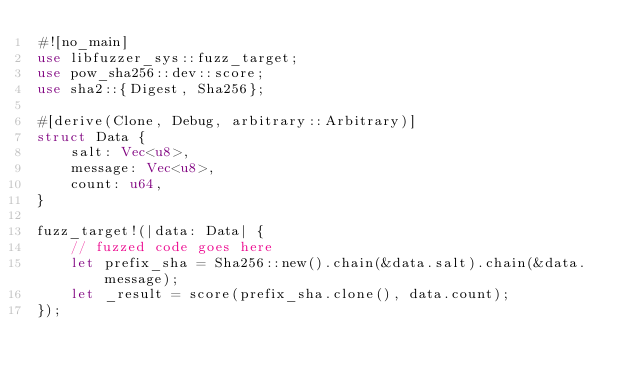Convert code to text. <code><loc_0><loc_0><loc_500><loc_500><_Rust_>#![no_main]
use libfuzzer_sys::fuzz_target;
use pow_sha256::dev::score;
use sha2::{Digest, Sha256};

#[derive(Clone, Debug, arbitrary::Arbitrary)]
struct Data {
    salt: Vec<u8>,
    message: Vec<u8>,
    count: u64,
}

fuzz_target!(|data: Data| {
    // fuzzed code goes here
    let prefix_sha = Sha256::new().chain(&data.salt).chain(&data.message);
    let _result = score(prefix_sha.clone(), data.count);
});
</code> 